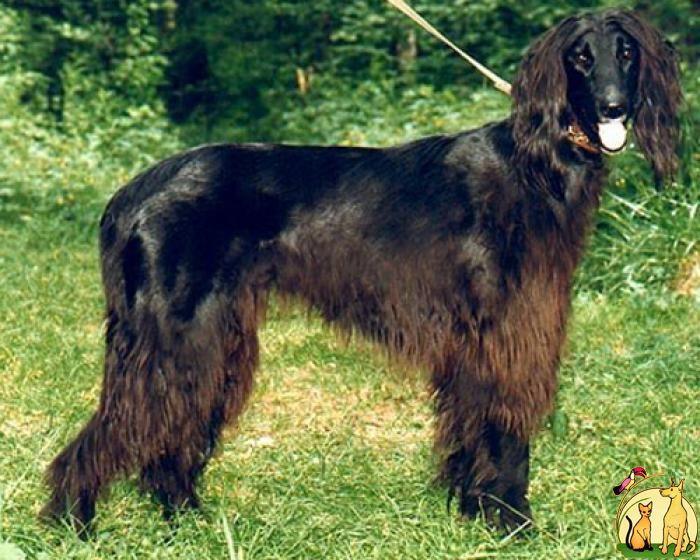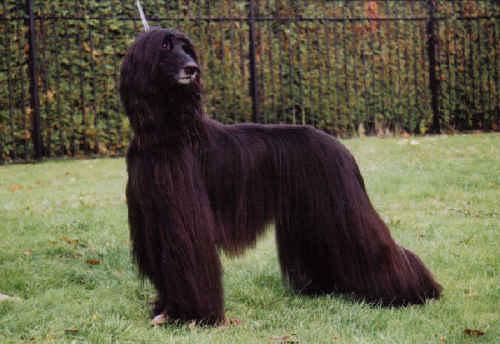The first image is the image on the left, the second image is the image on the right. Evaluate the accuracy of this statement regarding the images: "The left and right image contains the same number of dogs facing opposite directions.". Is it true? Answer yes or no. Yes. The first image is the image on the left, the second image is the image on the right. Assess this claim about the two images: "The dogs are oriented in opposite directions.". Correct or not? Answer yes or no. Yes. 